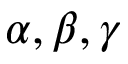<formula> <loc_0><loc_0><loc_500><loc_500>\alpha , \beta , \gamma</formula> 